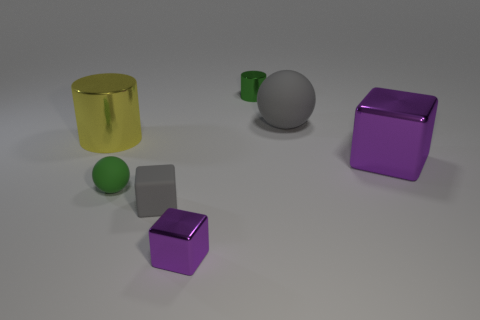Are there any purple blocks behind the shiny cube that is behind the tiny gray thing?
Offer a terse response. No. There is a gray thing behind the large yellow thing; what is it made of?
Give a very brief answer. Rubber. Does the purple cube that is behind the gray block have the same material as the cylinder in front of the green metal cylinder?
Provide a short and direct response. Yes. Are there the same number of green cylinders that are in front of the large cube and green objects that are in front of the yellow cylinder?
Provide a short and direct response. No. What number of big brown cylinders have the same material as the small cylinder?
Your response must be concise. 0. There is a shiny thing that is the same color as the big cube; what shape is it?
Make the answer very short. Cube. What is the size of the gray cube to the right of the metallic cylinder on the left side of the rubber cube?
Offer a terse response. Small. Is the shape of the gray rubber thing in front of the big purple shiny block the same as the purple metal object left of the large purple thing?
Give a very brief answer. Yes. Are there an equal number of gray blocks behind the tiny green shiny object and red cylinders?
Provide a short and direct response. Yes. What is the color of the tiny thing that is the same shape as the large rubber object?
Give a very brief answer. Green. 